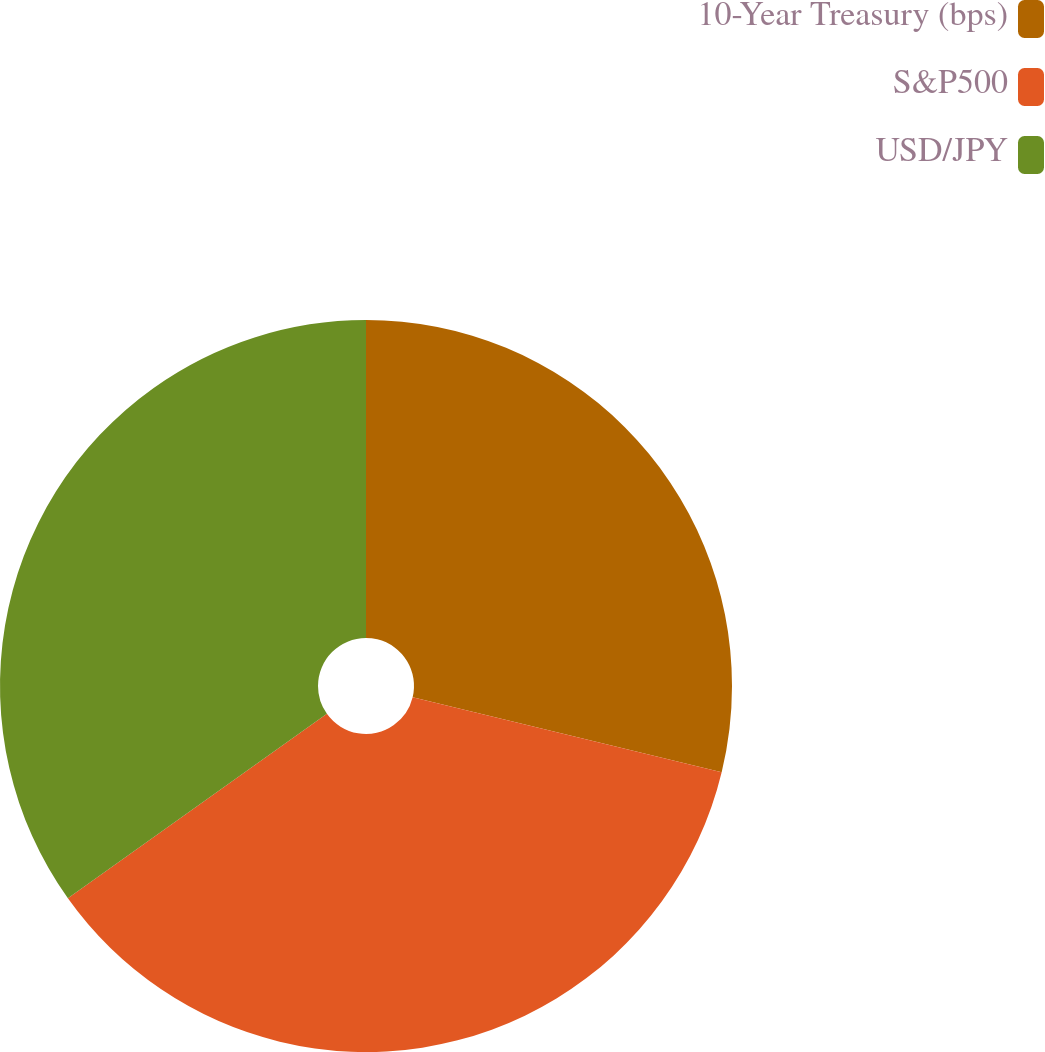Convert chart to OTSL. <chart><loc_0><loc_0><loc_500><loc_500><pie_chart><fcel>10-Year Treasury (bps)<fcel>S&P500<fcel>USD/JPY<nl><fcel>28.79%<fcel>36.36%<fcel>34.85%<nl></chart> 